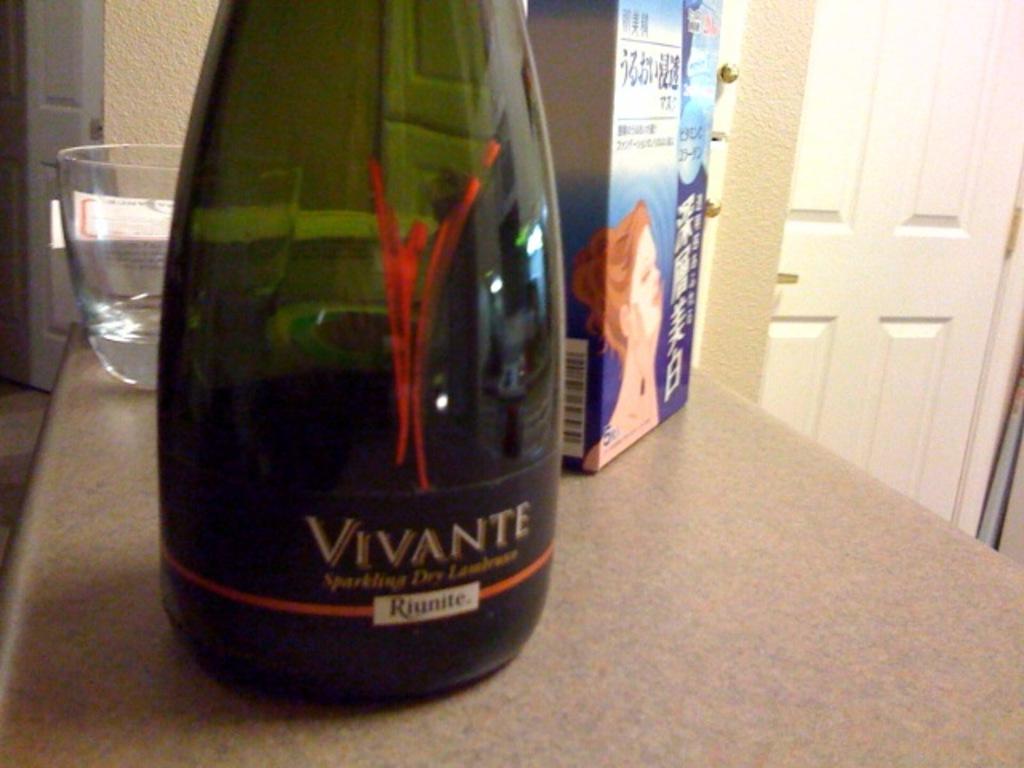What brand of wine is this?
Offer a very short reply. Vivante. What word is in the white box at the bottom of the label of the bottle?
Offer a terse response. Riunite. 